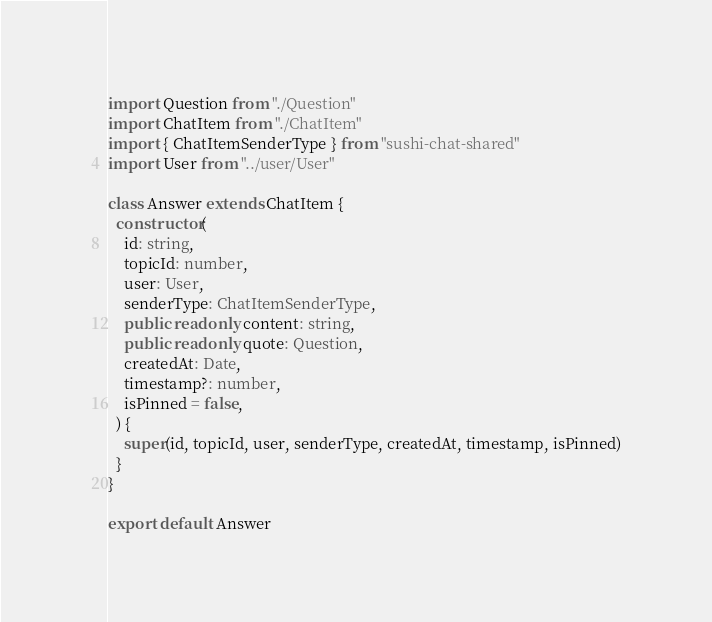Convert code to text. <code><loc_0><loc_0><loc_500><loc_500><_TypeScript_>import Question from "./Question"
import ChatItem from "./ChatItem"
import { ChatItemSenderType } from "sushi-chat-shared"
import User from "../user/User"

class Answer extends ChatItem {
  constructor(
    id: string,
    topicId: number,
    user: User,
    senderType: ChatItemSenderType,
    public readonly content: string,
    public readonly quote: Question,
    createdAt: Date,
    timestamp?: number,
    isPinned = false,
  ) {
    super(id, topicId, user, senderType, createdAt, timestamp, isPinned)
  }
}

export default Answer
</code> 